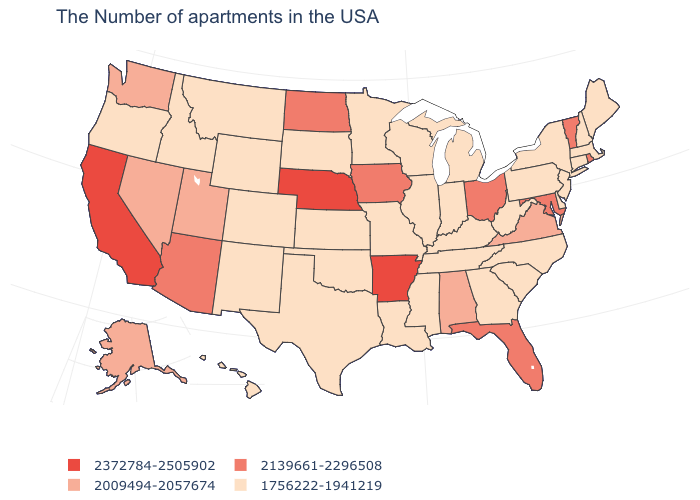What is the lowest value in states that border Missouri?
Give a very brief answer. 1756222-1941219. What is the value of Massachusetts?
Be succinct. 1756222-1941219. What is the value of New York?
Write a very short answer. 1756222-1941219. Among the states that border Maine , which have the highest value?
Quick response, please. New Hampshire. Does Hawaii have the same value as Alaska?
Answer briefly. No. What is the value of Oregon?
Answer briefly. 1756222-1941219. Does the map have missing data?
Write a very short answer. No. Name the states that have a value in the range 2139661-2296508?
Give a very brief answer. Rhode Island, Vermont, Maryland, Ohio, Florida, Iowa, North Dakota, Arizona. Which states hav the highest value in the South?
Quick response, please. Arkansas. Does New Mexico have the same value as Arkansas?
Answer briefly. No. Does the map have missing data?
Be succinct. No. What is the highest value in states that border Tennessee?
Write a very short answer. 2372784-2505902. Which states have the highest value in the USA?
Concise answer only. Arkansas, Nebraska, California. Name the states that have a value in the range 2372784-2505902?
Be succinct. Arkansas, Nebraska, California. Does Missouri have a higher value than Oklahoma?
Concise answer only. No. 